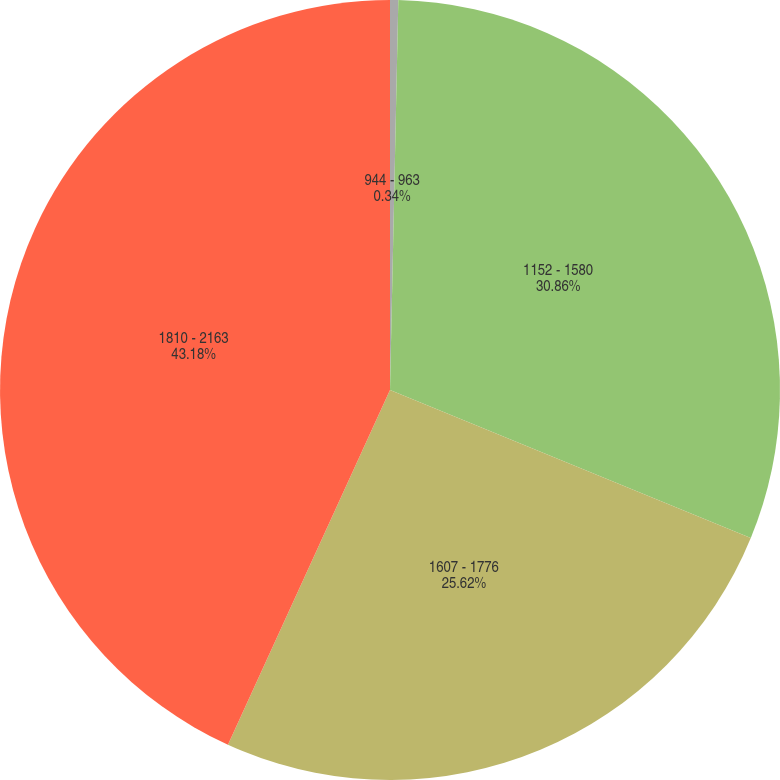<chart> <loc_0><loc_0><loc_500><loc_500><pie_chart><fcel>944 - 963<fcel>1152 - 1580<fcel>1607 - 1776<fcel>1810 - 2163<nl><fcel>0.34%<fcel>30.86%<fcel>25.62%<fcel>43.18%<nl></chart> 